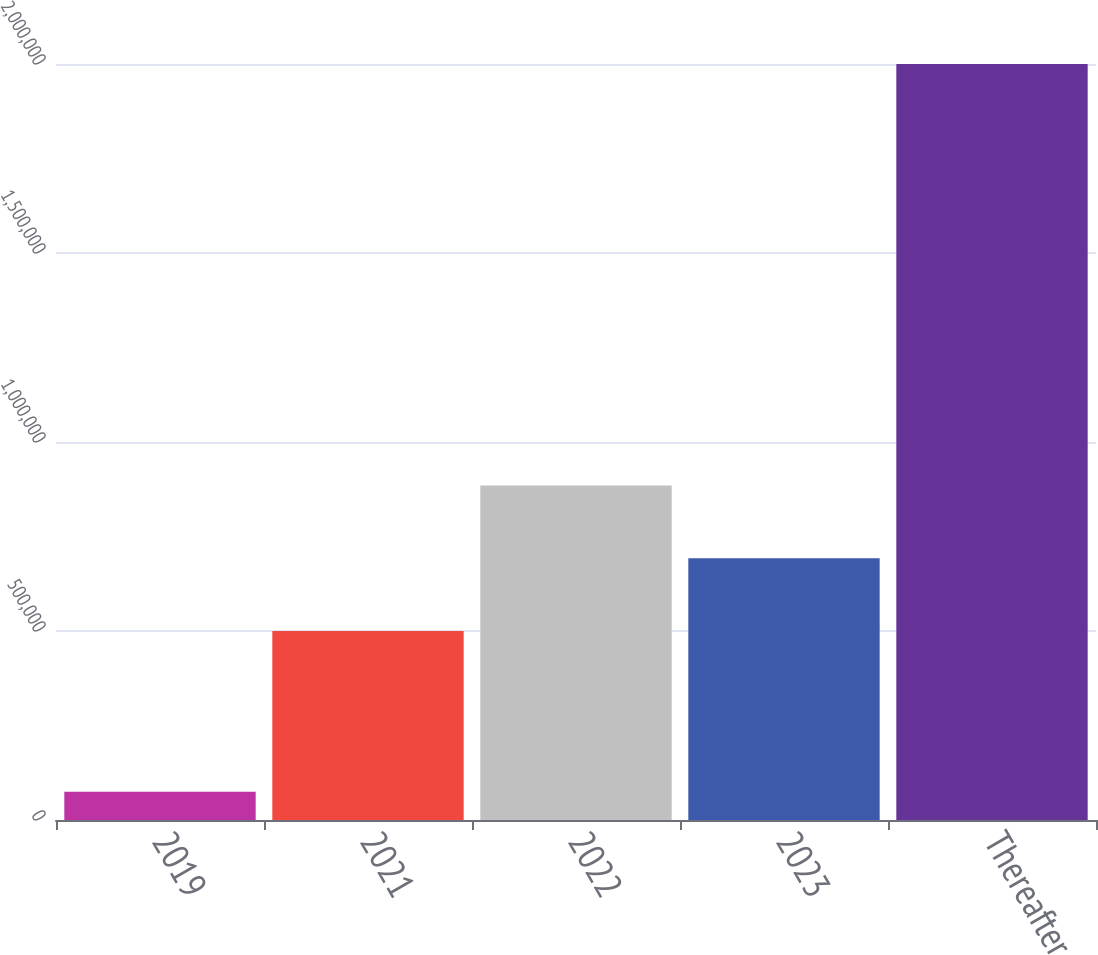Convert chart. <chart><loc_0><loc_0><loc_500><loc_500><bar_chart><fcel>2019<fcel>2021<fcel>2022<fcel>2023<fcel>Thereafter<nl><fcel>75000<fcel>500000<fcel>885000<fcel>692500<fcel>2e+06<nl></chart> 